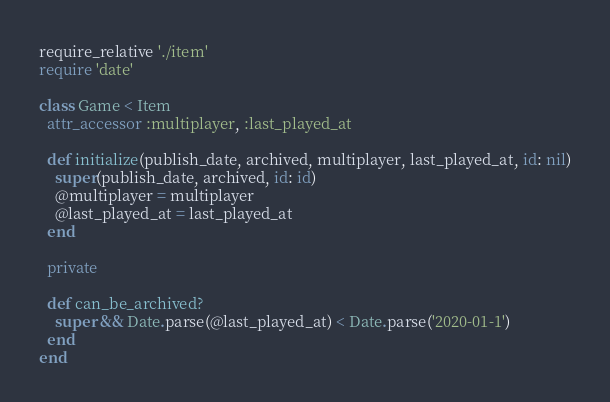Convert code to text. <code><loc_0><loc_0><loc_500><loc_500><_Ruby_>require_relative './item'
require 'date'

class Game < Item
  attr_accessor :multiplayer, :last_played_at

  def initialize(publish_date, archived, multiplayer, last_played_at, id: nil)
    super(publish_date, archived, id: id)
    @multiplayer = multiplayer
    @last_played_at = last_played_at
  end

  private

  def can_be_archived?
    super && Date.parse(@last_played_at) < Date.parse('2020-01-1')
  end
end
</code> 